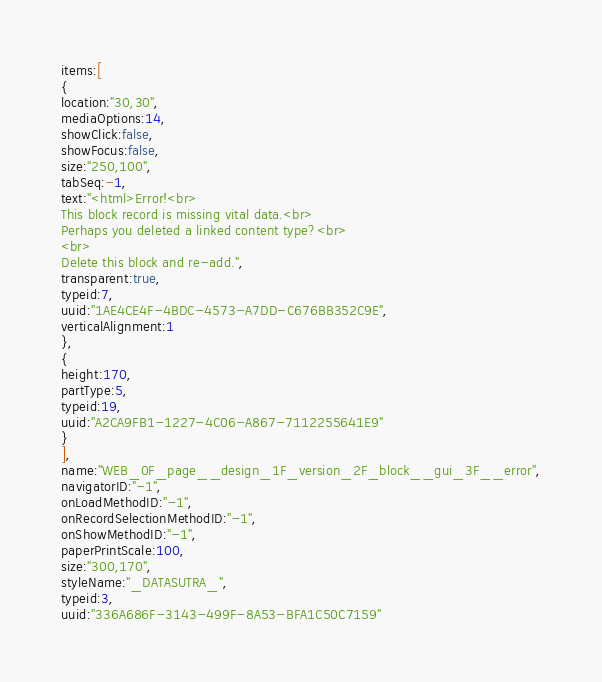Convert code to text. <code><loc_0><loc_0><loc_500><loc_500><_VisualBasic_>items:[
{
location:"30,30",
mediaOptions:14,
showClick:false,
showFocus:false,
size:"250,100",
tabSeq:-1,
text:"<html>Error!<br>
This block record is missing vital data.<br>
Perhaps you deleted a linked content type?<br>
<br>
Delete this block and re-add.",
transparent:true,
typeid:7,
uuid:"1AE4CE4F-4BDC-4573-A7DD-C676BB352C9E",
verticalAlignment:1
},
{
height:170,
partType:5,
typeid:19,
uuid:"A2CA9FB1-1227-4C06-A867-7112255641E9"
}
],
name:"WEB_0F_page__design_1F_version_2F_block__gui_3F__error",
navigatorID:"-1",
onLoadMethodID:"-1",
onRecordSelectionMethodID:"-1",
onShowMethodID:"-1",
paperPrintScale:100,
size:"300,170",
styleName:"_DATASUTRA_",
typeid:3,
uuid:"336A686F-3143-499F-8A53-BFA1C50C7159"</code> 